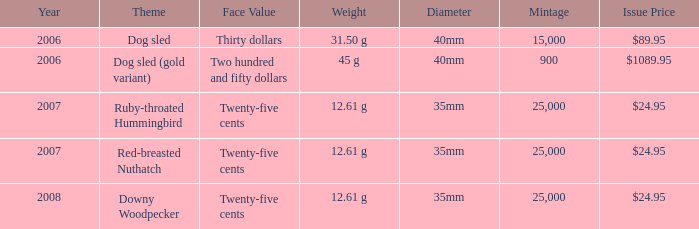What is the MIntage after 2006 of the Ruby-Throated Hummingbird Theme coin? 25000.0. 